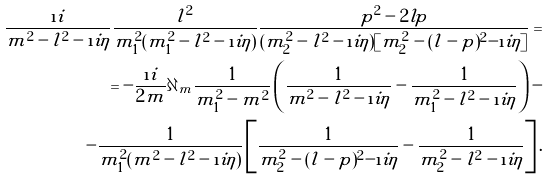Convert formula to latex. <formula><loc_0><loc_0><loc_500><loc_500>\frac { \i i } { m ^ { 2 } - l ^ { 2 } - \i i \eta } \frac { l ^ { 2 } } { m _ { 1 } ^ { 2 } ( m _ { 1 } ^ { 2 } - l ^ { 2 } - \i i \eta ) } \frac { p ^ { 2 } - 2 l p } { ( m _ { 2 } ^ { 2 } - l ^ { 2 } - \i i \eta ) [ m _ { 2 } ^ { 2 } - ( l - p ) ^ { 2 } - \i i \eta ] } = \\ = - \frac { \i i } { 2 m } \partial _ { m } \frac { 1 } { m _ { 1 } ^ { 2 } - m ^ { 2 } } \left ( \frac { 1 } { m ^ { 2 } - l ^ { 2 } - \i i \eta } - \frac { 1 } { m _ { 1 } ^ { 2 } - l ^ { 2 } - \i i \eta } \right ) - \\ - \frac { 1 } { m _ { 1 } ^ { 2 } ( m ^ { 2 } - l ^ { 2 } - \i i \eta ) } \left [ \frac { 1 } { m _ { 2 } ^ { 2 } - ( l - p ) ^ { 2 } - \i i \eta } - \frac { 1 } { m _ { 2 } ^ { 2 } - l ^ { 2 } - \i i \eta } \right ] .</formula> 